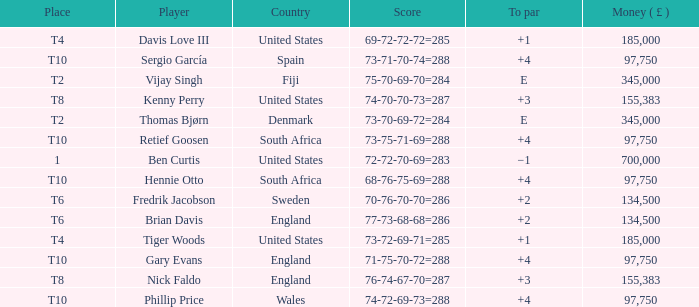What is the Place of Davis Love III with a To Par of +1? T4. Could you help me parse every detail presented in this table? {'header': ['Place', 'Player', 'Country', 'Score', 'To par', 'Money ( £ )'], 'rows': [['T4', 'Davis Love III', 'United States', '69-72-72-72=285', '+1', '185,000'], ['T10', 'Sergio García', 'Spain', '73-71-70-74=288', '+4', '97,750'], ['T2', 'Vijay Singh', 'Fiji', '75-70-69-70=284', 'E', '345,000'], ['T8', 'Kenny Perry', 'United States', '74-70-70-73=287', '+3', '155,383'], ['T2', 'Thomas Bjørn', 'Denmark', '73-70-69-72=284', 'E', '345,000'], ['T10', 'Retief Goosen', 'South Africa', '73-75-71-69=288', '+4', '97,750'], ['1', 'Ben Curtis', 'United States', '72-72-70-69=283', '−1', '700,000'], ['T10', 'Hennie Otto', 'South Africa', '68-76-75-69=288', '+4', '97,750'], ['T6', 'Fredrik Jacobson', 'Sweden', '70-76-70-70=286', '+2', '134,500'], ['T6', 'Brian Davis', 'England', '77-73-68-68=286', '+2', '134,500'], ['T4', 'Tiger Woods', 'United States', '73-72-69-71=285', '+1', '185,000'], ['T10', 'Gary Evans', 'England', '71-75-70-72=288', '+4', '97,750'], ['T8', 'Nick Faldo', 'England', '76-74-67-70=287', '+3', '155,383'], ['T10', 'Phillip Price', 'Wales', '74-72-69-73=288', '+4', '97,750']]} 